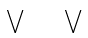Convert formula to latex. <formula><loc_0><loc_0><loc_500><loc_500>\bigvee \quad \bigvee</formula> 